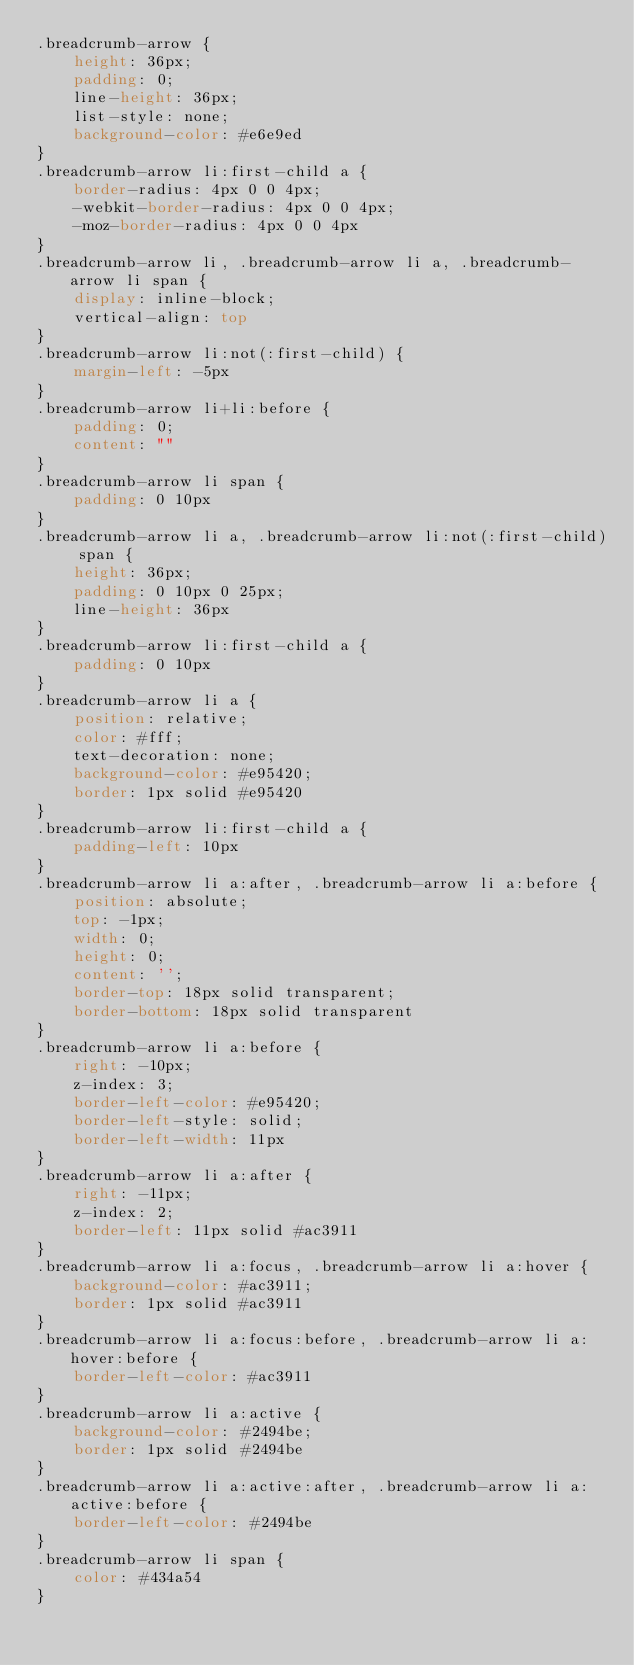<code> <loc_0><loc_0><loc_500><loc_500><_CSS_>.breadcrumb-arrow {
    height: 36px;
    padding: 0;
    line-height: 36px;
    list-style: none;
    background-color: #e6e9ed
}
.breadcrumb-arrow li:first-child a {
    border-radius: 4px 0 0 4px;
    -webkit-border-radius: 4px 0 0 4px;
    -moz-border-radius: 4px 0 0 4px
}
.breadcrumb-arrow li, .breadcrumb-arrow li a, .breadcrumb-arrow li span {
    display: inline-block;
    vertical-align: top
}
.breadcrumb-arrow li:not(:first-child) {
    margin-left: -5px
}
.breadcrumb-arrow li+li:before {
    padding: 0;
    content: ""
}
.breadcrumb-arrow li span {
    padding: 0 10px
}
.breadcrumb-arrow li a, .breadcrumb-arrow li:not(:first-child) span {
    height: 36px;
    padding: 0 10px 0 25px;
    line-height: 36px
}
.breadcrumb-arrow li:first-child a {
    padding: 0 10px
}
.breadcrumb-arrow li a {
    position: relative;
    color: #fff;
    text-decoration: none;
    background-color: #e95420;
    border: 1px solid #e95420
}
.breadcrumb-arrow li:first-child a {
    padding-left: 10px
}
.breadcrumb-arrow li a:after, .breadcrumb-arrow li a:before {
    position: absolute;
    top: -1px;
    width: 0;
    height: 0;
    content: '';
    border-top: 18px solid transparent;
    border-bottom: 18px solid transparent
}
.breadcrumb-arrow li a:before {
    right: -10px;
    z-index: 3;
    border-left-color: #e95420;
    border-left-style: solid;
    border-left-width: 11px
}
.breadcrumb-arrow li a:after {
    right: -11px;
    z-index: 2;
    border-left: 11px solid #ac3911
}
.breadcrumb-arrow li a:focus, .breadcrumb-arrow li a:hover {
    background-color: #ac3911;
    border: 1px solid #ac3911
}
.breadcrumb-arrow li a:focus:before, .breadcrumb-arrow li a:hover:before {
    border-left-color: #ac3911
}
.breadcrumb-arrow li a:active {
    background-color: #2494be;
    border: 1px solid #2494be
}
.breadcrumb-arrow li a:active:after, .breadcrumb-arrow li a:active:before {
    border-left-color: #2494be
}
.breadcrumb-arrow li span {
    color: #434a54
}</code> 